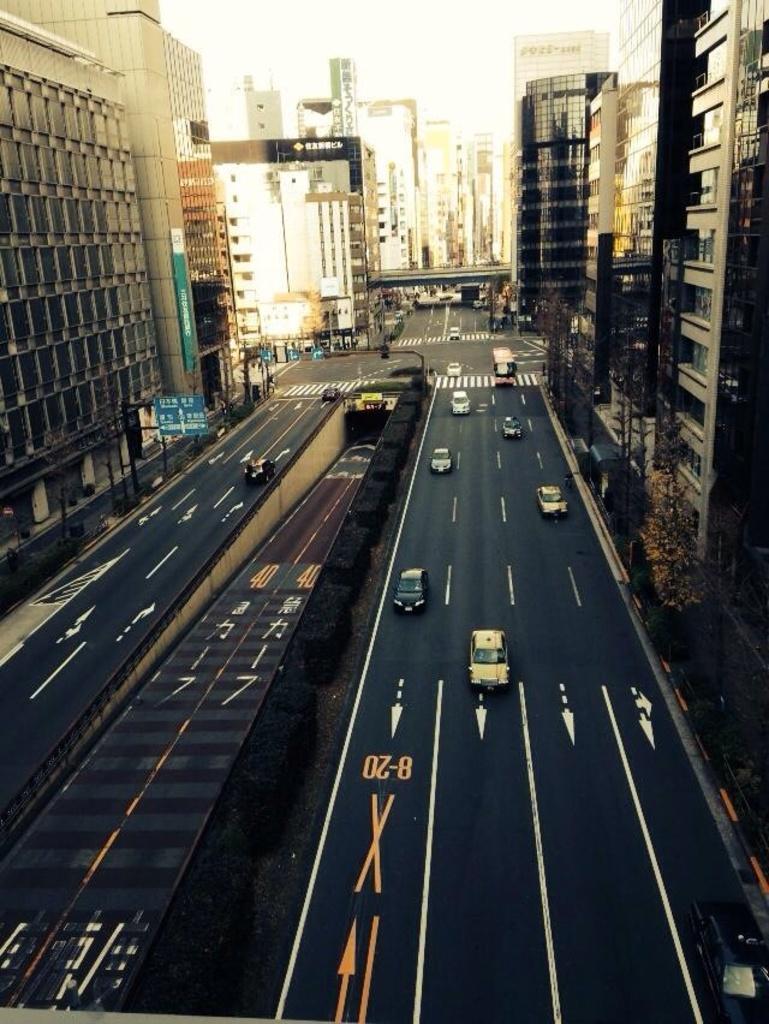How would you summarize this image in a sentence or two? In this image there are roads at the bottom. In between the words there is a tunnel. There are buildings on either side of the road. On the road there are vehicles. There are few boards and poles on the footpath. 